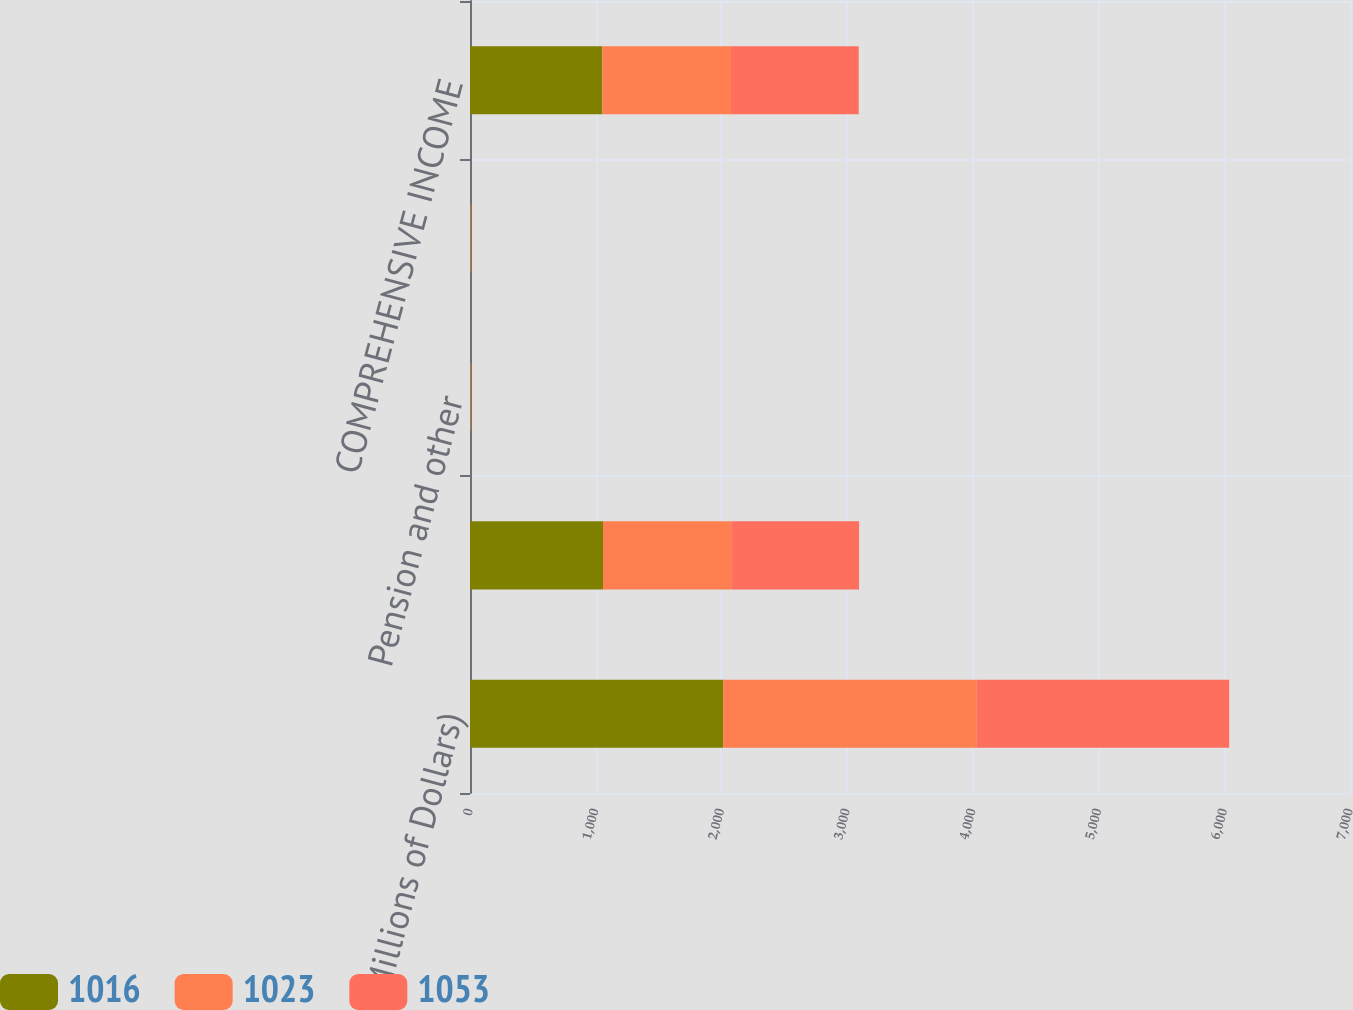Convert chart. <chart><loc_0><loc_0><loc_500><loc_500><stacked_bar_chart><ecel><fcel>(Millions of Dollars)<fcel>NET INCOME<fcel>Pension and other<fcel>TOTAL OTHER COMPREHENSIVE<fcel>COMPREHENSIVE INCOME<nl><fcel>1016<fcel>2014<fcel>1058<fcel>5<fcel>5<fcel>1053<nl><fcel>1023<fcel>2013<fcel>1020<fcel>3<fcel>3<fcel>1023<nl><fcel>1053<fcel>2012<fcel>1017<fcel>1<fcel>1<fcel>1016<nl></chart> 